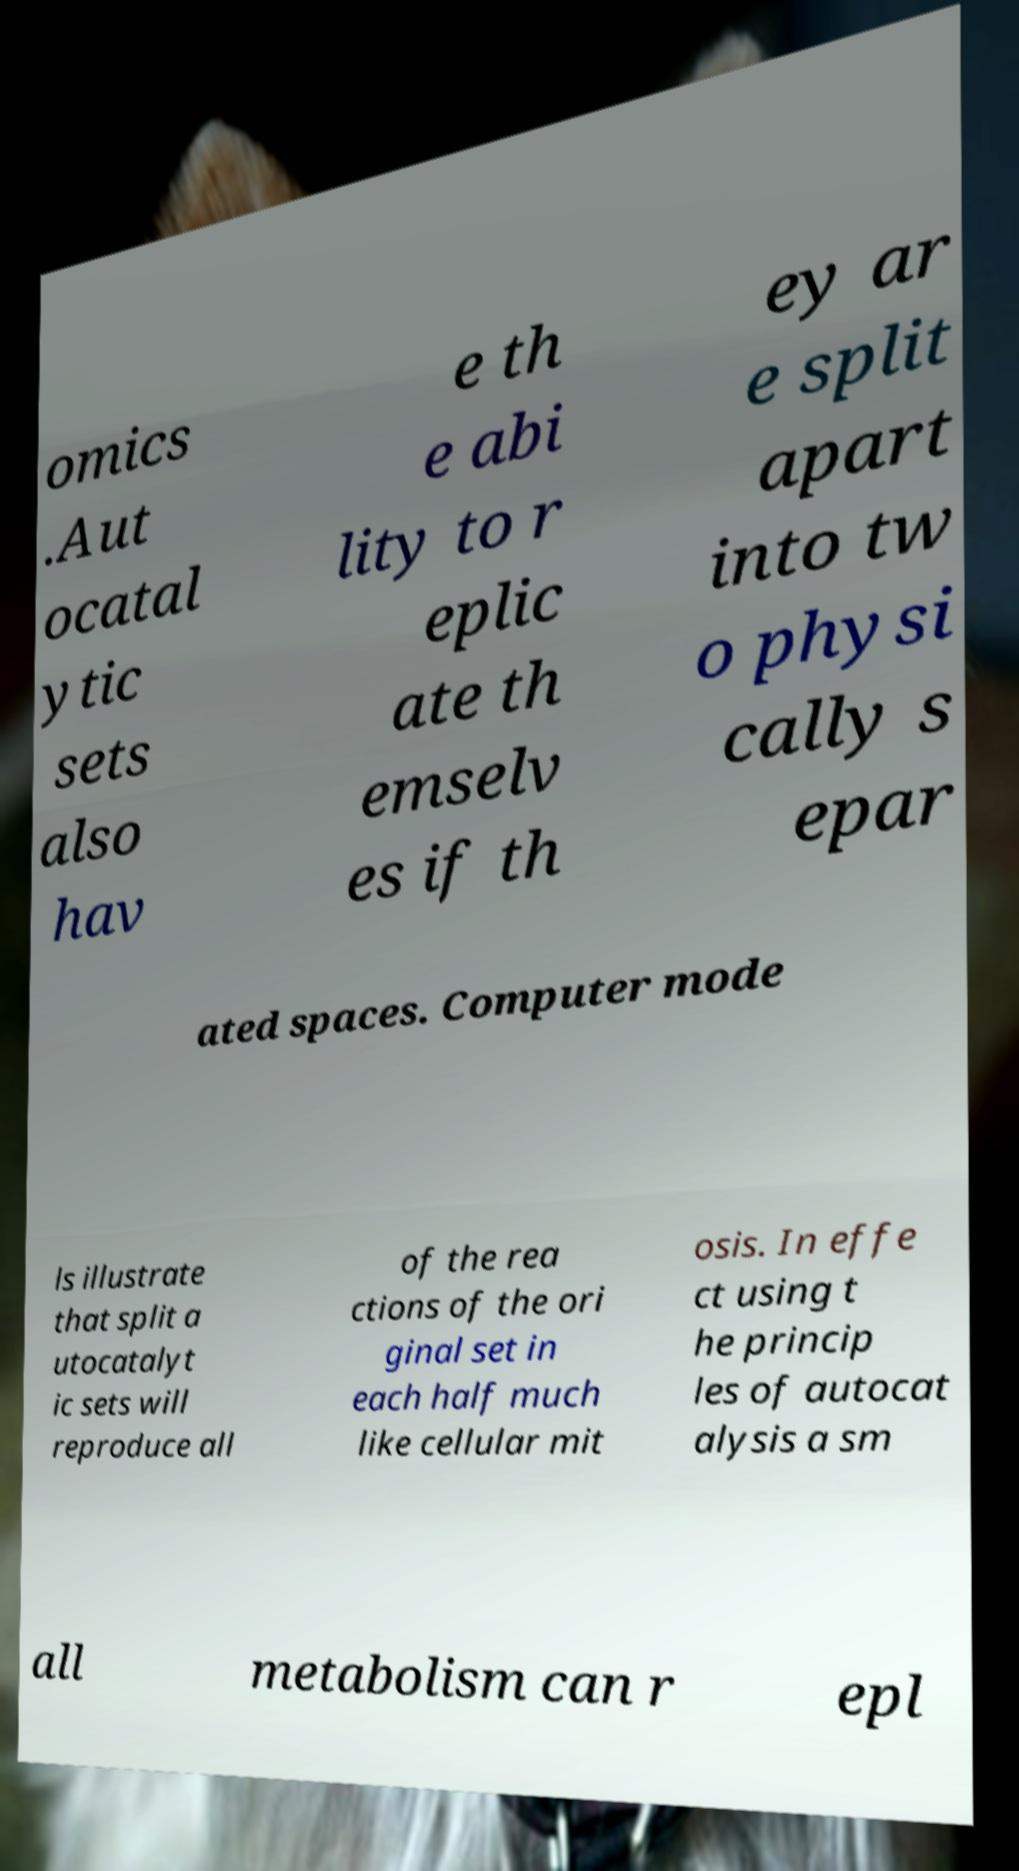Can you read and provide the text displayed in the image?This photo seems to have some interesting text. Can you extract and type it out for me? omics .Aut ocatal ytic sets also hav e th e abi lity to r eplic ate th emselv es if th ey ar e split apart into tw o physi cally s epar ated spaces. Computer mode ls illustrate that split a utocatalyt ic sets will reproduce all of the rea ctions of the ori ginal set in each half much like cellular mit osis. In effe ct using t he princip les of autocat alysis a sm all metabolism can r epl 